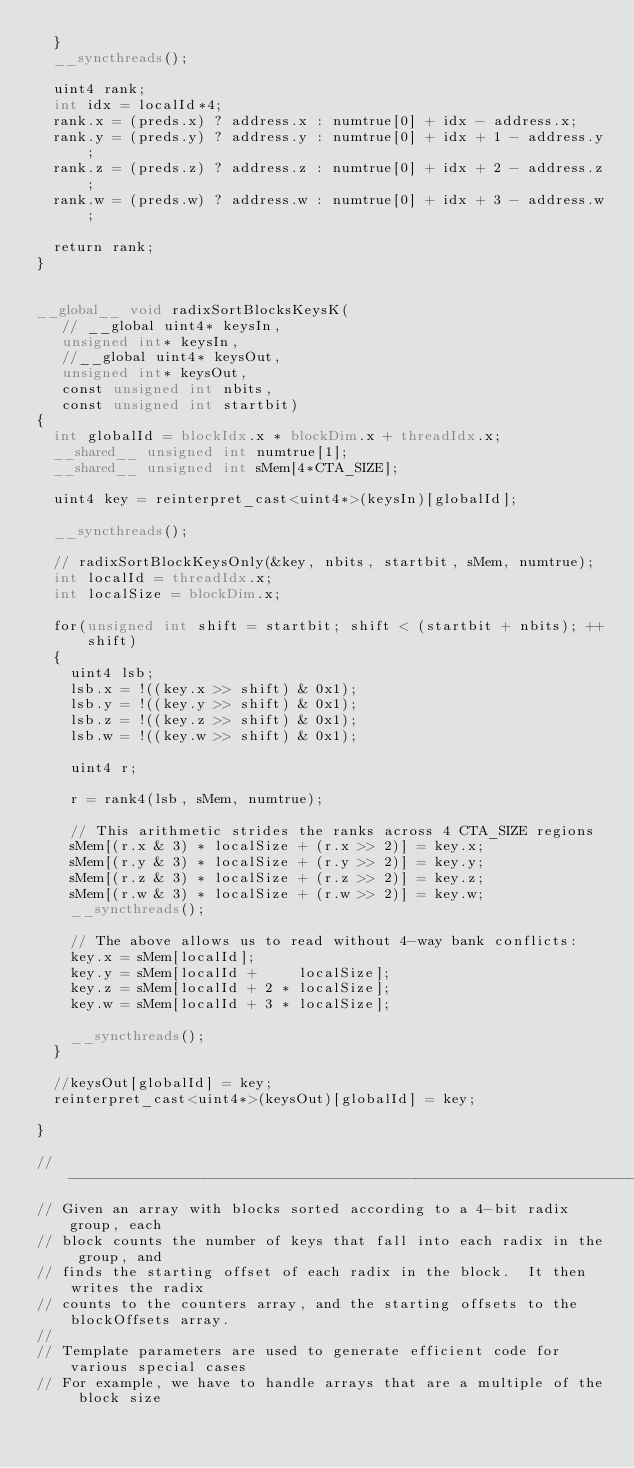<code> <loc_0><loc_0><loc_500><loc_500><_Cuda_>  }
  __syncthreads();

  uint4 rank;
  int idx = localId*4;
  rank.x = (preds.x) ? address.x : numtrue[0] + idx - address.x;
  rank.y = (preds.y) ? address.y : numtrue[0] + idx + 1 - address.y;
  rank.z = (preds.z) ? address.z : numtrue[0] + idx + 2 - address.z;
  rank.w = (preds.w) ? address.w : numtrue[0] + idx + 3 - address.w;

  return rank;
}


__global__ void radixSortBlocksKeysK(
   // __global uint4* keysIn, 
   unsigned int* keysIn, 
   //__global uint4* keysOut,
   unsigned int* keysOut,
   const unsigned int nbits,
   const unsigned int startbit)
{
  int globalId = blockIdx.x * blockDim.x + threadIdx.x;
  __shared__ unsigned int numtrue[1];
  __shared__ unsigned int sMem[4*CTA_SIZE];

  uint4 key = reinterpret_cast<uint4*>(keysIn)[globalId];

  __syncthreads();

  // radixSortBlockKeysOnly(&key, nbits, startbit, sMem, numtrue);
  int localId = threadIdx.x;
  int localSize = blockDim.x;

  for(unsigned int shift = startbit; shift < (startbit + nbits); ++shift)
  {
    uint4 lsb;
    lsb.x = !((key.x >> shift) & 0x1);
    lsb.y = !((key.y >> shift) & 0x1);
    lsb.z = !((key.z >> shift) & 0x1);
    lsb.w = !((key.w >> shift) & 0x1);

    uint4 r;

    r = rank4(lsb, sMem, numtrue);

    // This arithmetic strides the ranks across 4 CTA_SIZE regions
    sMem[(r.x & 3) * localSize + (r.x >> 2)] = key.x;
    sMem[(r.y & 3) * localSize + (r.y >> 2)] = key.y;
    sMem[(r.z & 3) * localSize + (r.z >> 2)] = key.z;
    sMem[(r.w & 3) * localSize + (r.w >> 2)] = key.w;
    __syncthreads();

    // The above allows us to read without 4-way bank conflicts:
    key.x = sMem[localId];
    key.y = sMem[localId +     localSize];
    key.z = sMem[localId + 2 * localSize];
    key.w = sMem[localId + 3 * localSize];

    __syncthreads();
  }

  //keysOut[globalId] = key;
  reinterpret_cast<uint4*>(keysOut)[globalId] = key;  
  
}

//----------------------------------------------------------------------------
// Given an array with blocks sorted according to a 4-bit radix group, each 
// block counts the number of keys that fall into each radix in the group, and 
// finds the starting offset of each radix in the block.  It then writes the radix 
// counts to the counters array, and the starting offsets to the blockOffsets array.
//
// Template parameters are used to generate efficient code for various special cases
// For example, we have to handle arrays that are a multiple of the block size </code> 